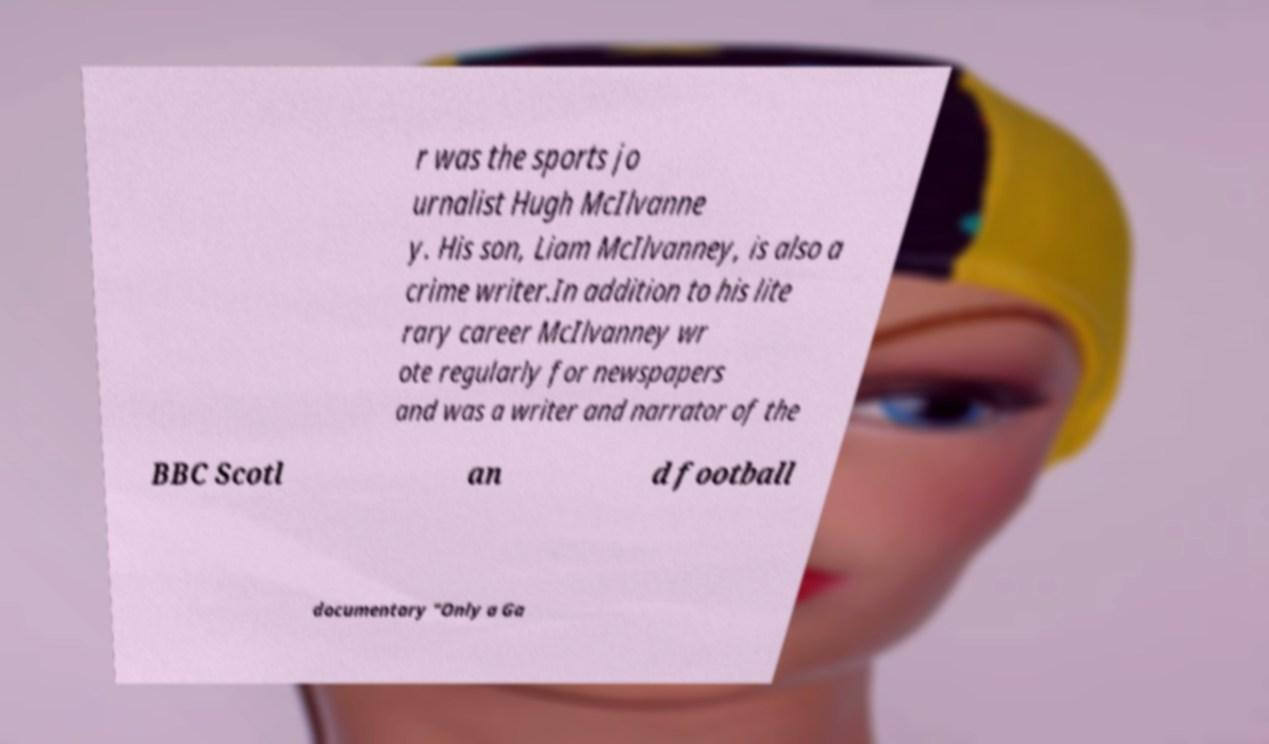There's text embedded in this image that I need extracted. Can you transcribe it verbatim? r was the sports jo urnalist Hugh McIlvanne y. His son, Liam McIlvanney, is also a crime writer.In addition to his lite rary career McIlvanney wr ote regularly for newspapers and was a writer and narrator of the BBC Scotl an d football documentary "Only a Ga 